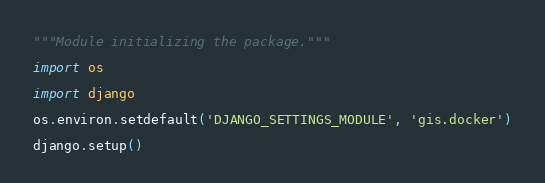Convert code to text. <code><loc_0><loc_0><loc_500><loc_500><_Python_>"""Module initializing the package."""

import os

import django

os.environ.setdefault('DJANGO_SETTINGS_MODULE', 'gis.docker')

django.setup()
</code> 